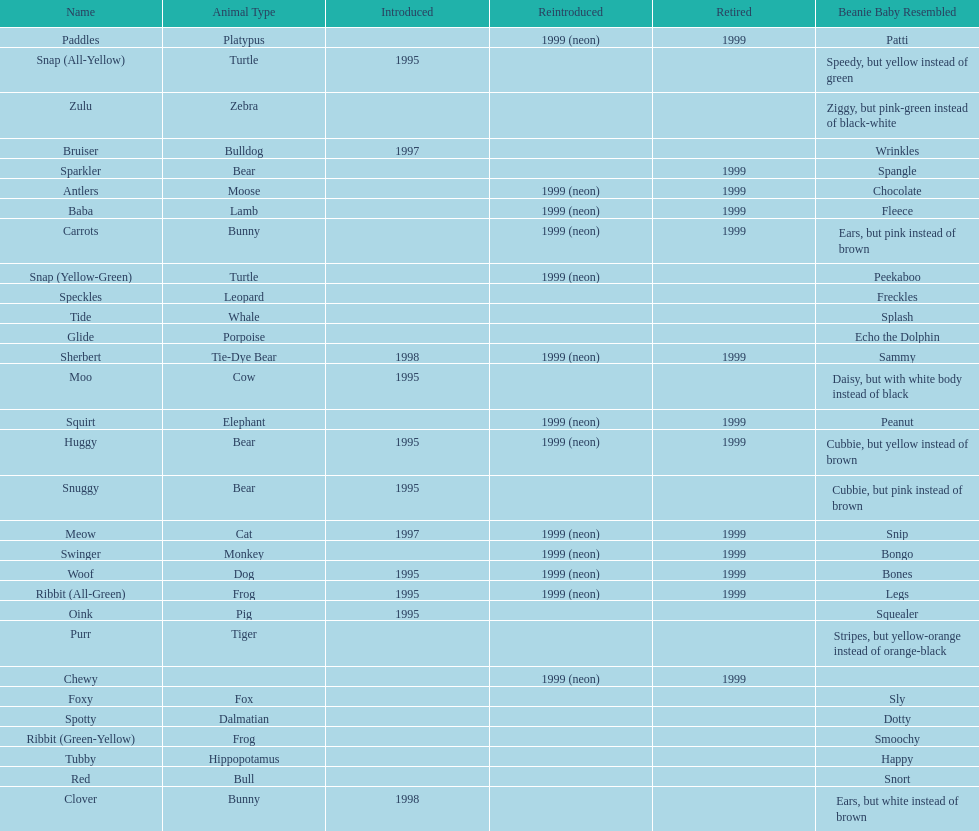How many monkey pillow pals were there? 1. 